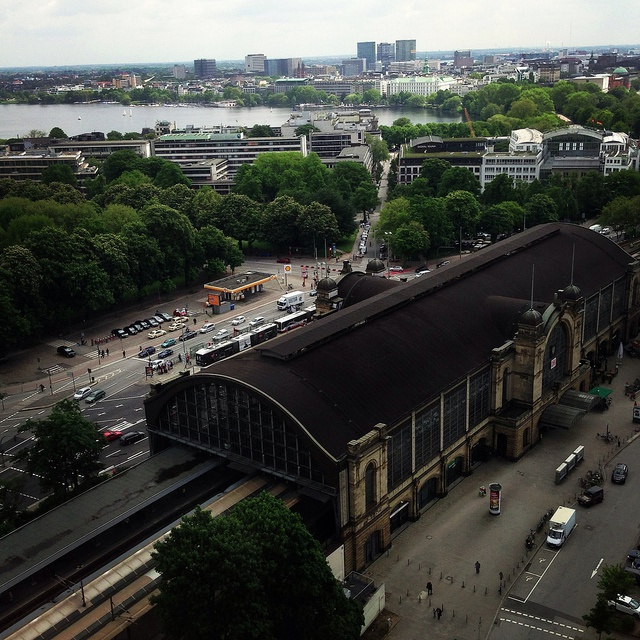Describe the objects in this image and their specific colors. I can see car in white, black, gray, darkgray, and lightgray tones, people in white, black, gray, and darkgray tones, train in white, black, lightgray, gray, and darkgray tones, truck in white, black, gray, and beige tones, and bus in white, black, lightgray, gray, and darkgray tones in this image. 